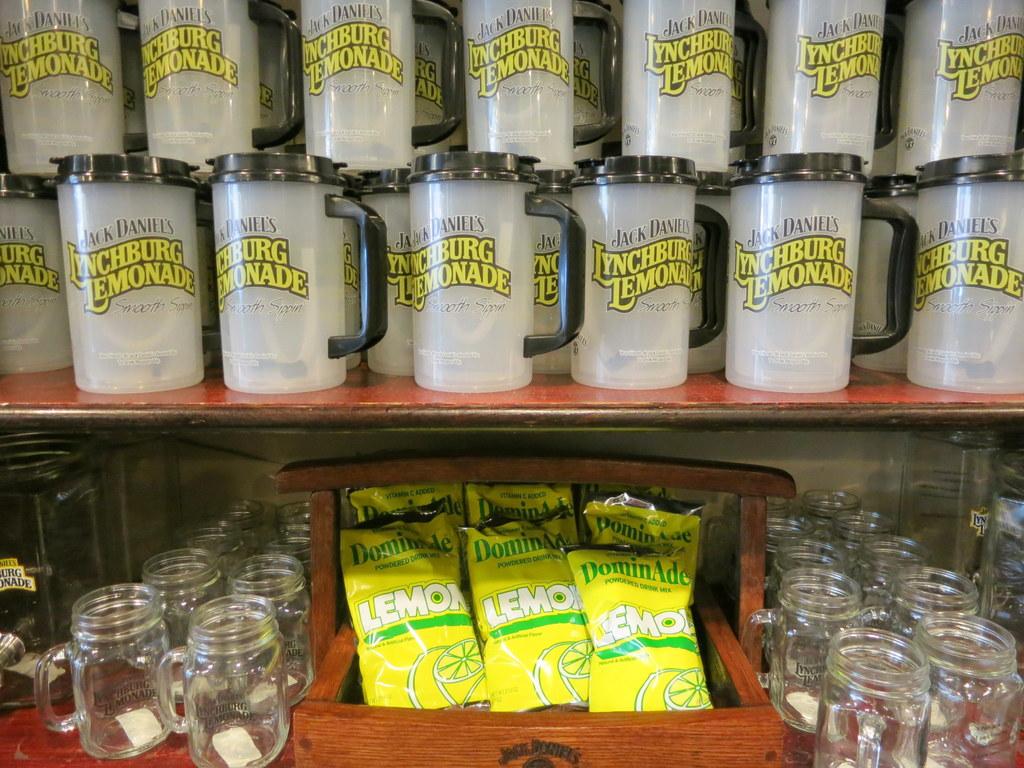What flavor is the candy?
Ensure brevity in your answer.  Lemon. What is the first letter of the name on the cups?
Make the answer very short. L. 